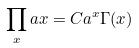Convert formula to latex. <formula><loc_0><loc_0><loc_500><loc_500>\prod _ { x } a x = C a ^ { x } \Gamma ( x )</formula> 